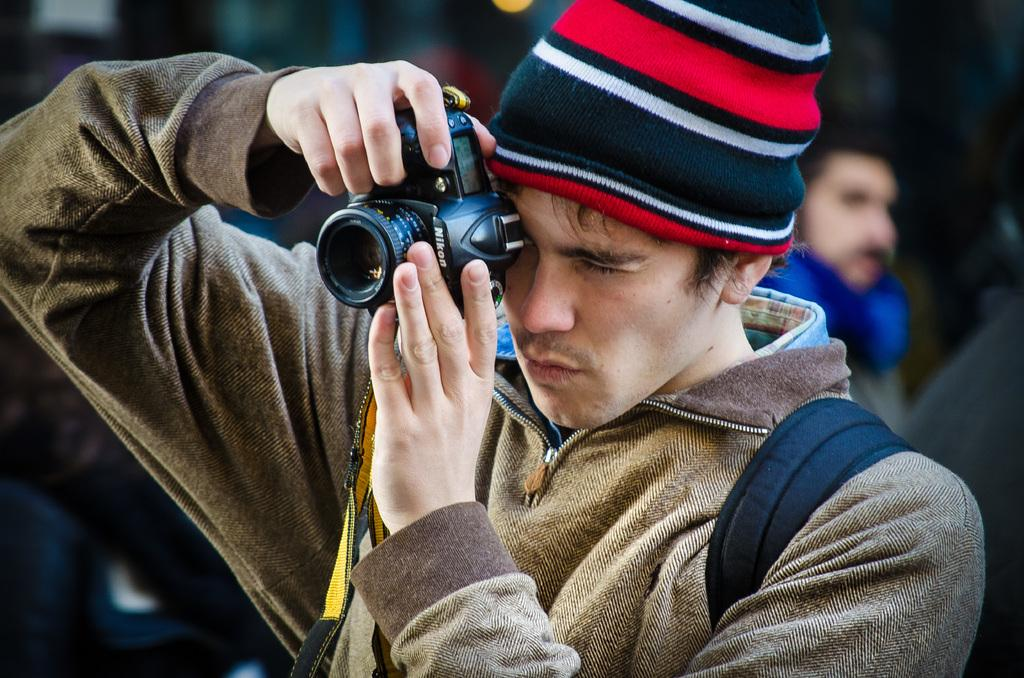What is the main subject of the image? The main subject of the image is a man in the middle of the image. What is the man wearing in the image? The man is wearing a jacket, a bag, a shirt, and a cap in the image. What is the man holding in the image? The man is holding a camera in the image. Are there any other people visible in the image? Yes, there is another man in the background of the image. What type of ornament can be seen hanging from the tree in the image? There is no tree or ornament present in the image; it features a man in the middle of the image. How much dirt is visible on the man's shoes in the image? There is no information about the man's shoes or the presence of dirt in the image. 